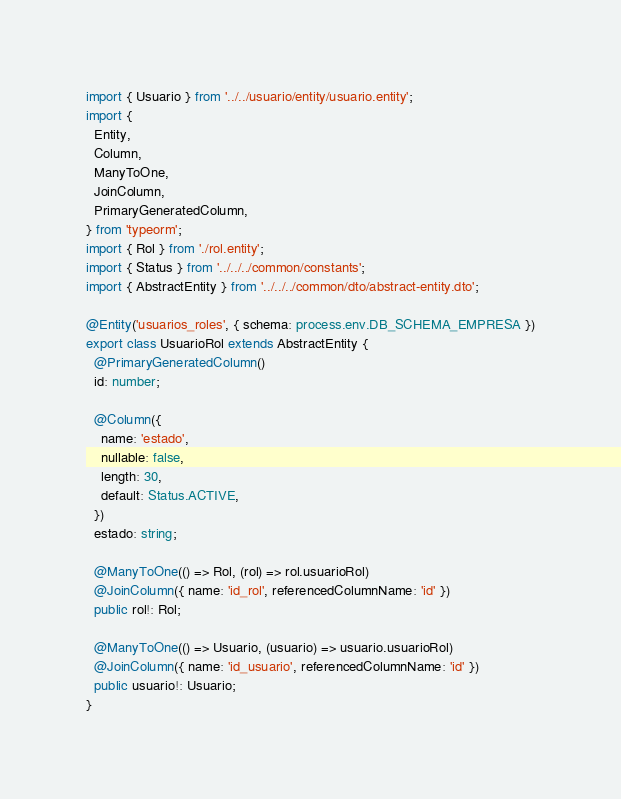Convert code to text. <code><loc_0><loc_0><loc_500><loc_500><_TypeScript_>import { Usuario } from '../../usuario/entity/usuario.entity';
import {
  Entity,
  Column,
  ManyToOne,
  JoinColumn,
  PrimaryGeneratedColumn,
} from 'typeorm';
import { Rol } from './rol.entity';
import { Status } from '../../../common/constants';
import { AbstractEntity } from '../../../common/dto/abstract-entity.dto';

@Entity('usuarios_roles', { schema: process.env.DB_SCHEMA_EMPRESA })
export class UsuarioRol extends AbstractEntity {
  @PrimaryGeneratedColumn()
  id: number;

  @Column({
    name: 'estado',
    nullable: false,
    length: 30,
    default: Status.ACTIVE,
  })
  estado: string;

  @ManyToOne(() => Rol, (rol) => rol.usuarioRol)
  @JoinColumn({ name: 'id_rol', referencedColumnName: 'id' })
  public rol!: Rol;

  @ManyToOne(() => Usuario, (usuario) => usuario.usuarioRol)
  @JoinColumn({ name: 'id_usuario', referencedColumnName: 'id' })
  public usuario!: Usuario;
}
</code> 